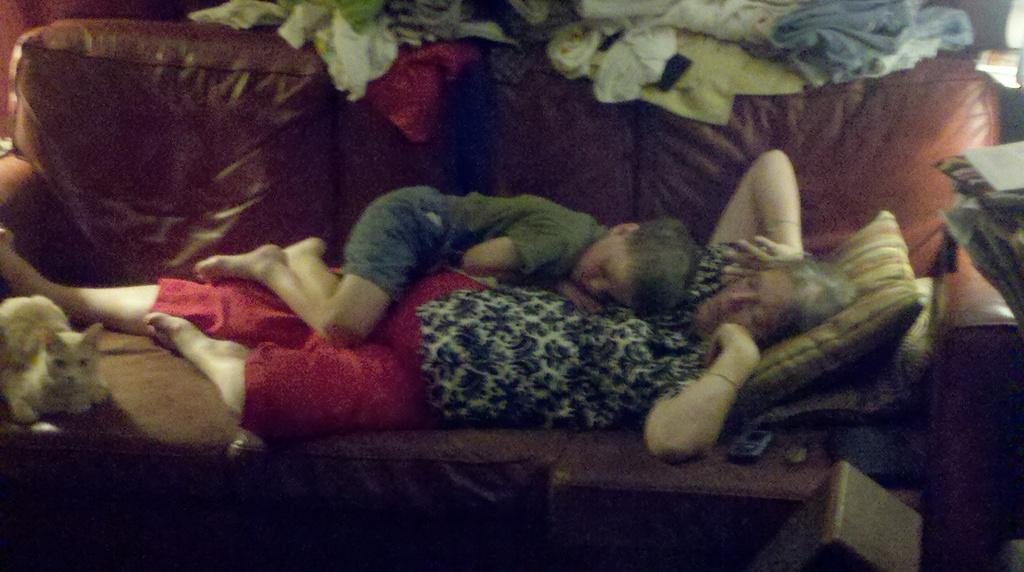What are the two people in the image doing? The two people are lying on a couch. What else can be seen around the couch? There are clothes visible around the couch. What type of animal is sitting on the couch? There is a cat sitting on the couch. What type of marble is the cat playing with on the couch? There is no marble present in the image; the cat is sitting on the couch. How many stars can be seen in the image? There are no stars visible in the image. 